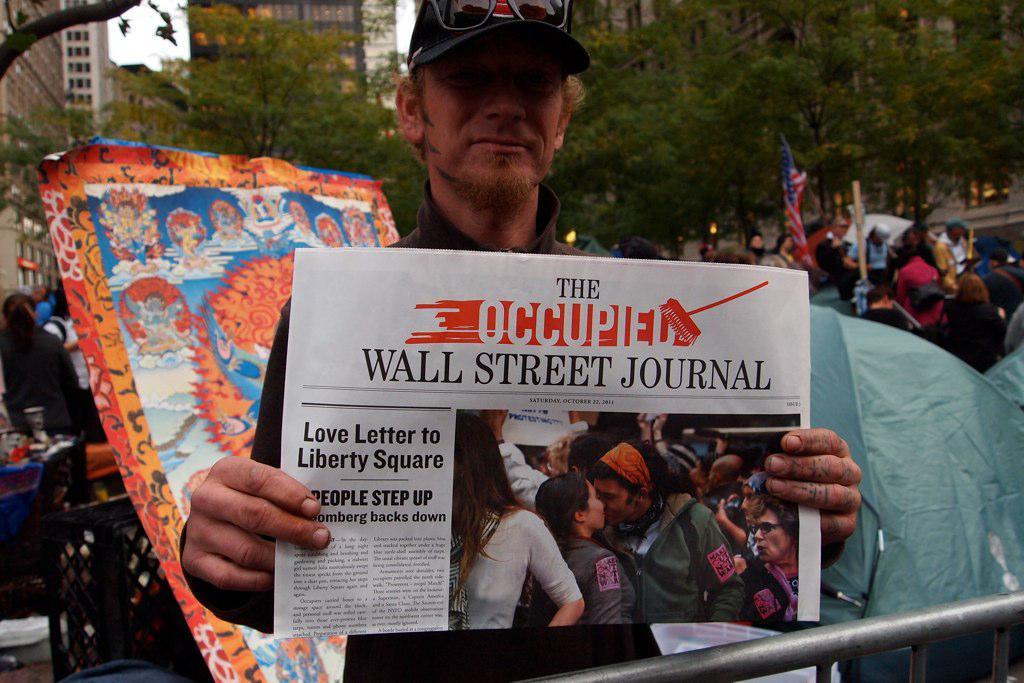What magazine was "love letter to liberty square" published in?
Provide a short and direct response. The wall street journal. 